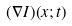Convert formula to latex. <formula><loc_0><loc_0><loc_500><loc_500>( \nabla I ) ( x ; t )</formula> 